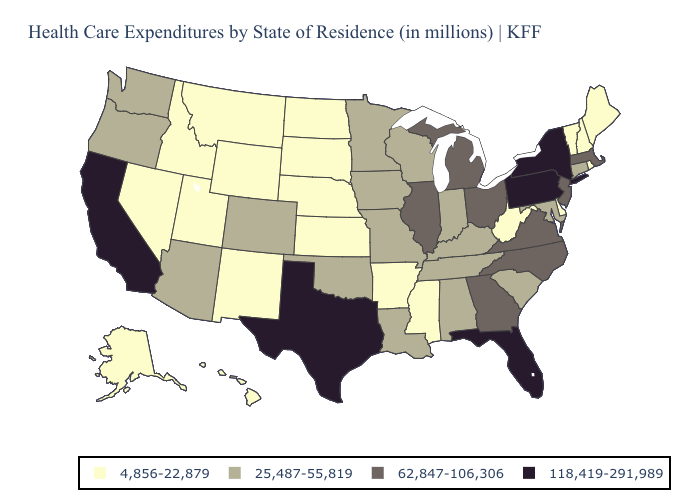What is the highest value in states that border Utah?
Quick response, please. 25,487-55,819. What is the lowest value in the West?
Quick response, please. 4,856-22,879. Does Delaware have a higher value than New Jersey?
Concise answer only. No. Does Colorado have a higher value than Connecticut?
Concise answer only. No. Which states have the lowest value in the West?
Quick response, please. Alaska, Hawaii, Idaho, Montana, Nevada, New Mexico, Utah, Wyoming. What is the highest value in states that border Illinois?
Write a very short answer. 25,487-55,819. Which states have the lowest value in the USA?
Answer briefly. Alaska, Arkansas, Delaware, Hawaii, Idaho, Kansas, Maine, Mississippi, Montana, Nebraska, Nevada, New Hampshire, New Mexico, North Dakota, Rhode Island, South Dakota, Utah, Vermont, West Virginia, Wyoming. Does Alaska have the lowest value in the West?
Give a very brief answer. Yes. Among the states that border Tennessee , which have the highest value?
Give a very brief answer. Georgia, North Carolina, Virginia. Name the states that have a value in the range 118,419-291,989?
Concise answer only. California, Florida, New York, Pennsylvania, Texas. What is the value of Delaware?
Concise answer only. 4,856-22,879. Does New Jersey have a higher value than Texas?
Keep it brief. No. Does Connecticut have the lowest value in the USA?
Be succinct. No. What is the value of Alaska?
Write a very short answer. 4,856-22,879. 